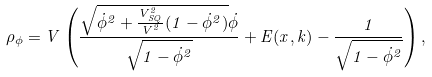<formula> <loc_0><loc_0><loc_500><loc_500>\rho _ { \phi } = V \left ( \frac { \sqrt { \dot { \phi } ^ { 2 } + \frac { V _ { S Q } ^ { 2 } } { V ^ { 2 } } ( 1 - \dot { \phi } ^ { 2 } ) } \dot { \phi } } { \sqrt { 1 - \dot { \phi } ^ { 2 } } } + E ( x , k ) - \frac { 1 } { \sqrt { 1 - \dot { \phi } ^ { 2 } } } \right ) ,</formula> 